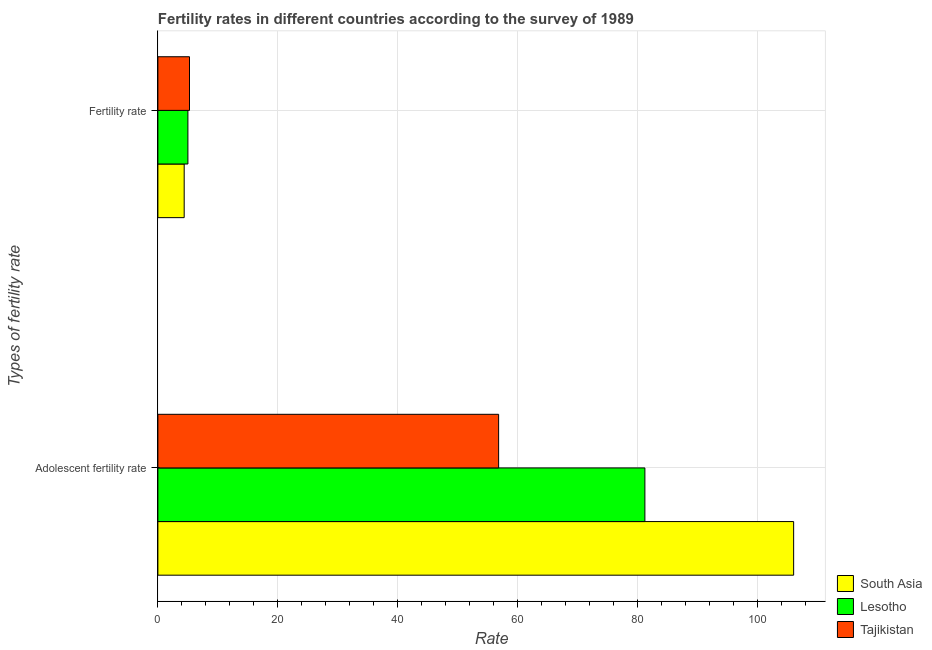How many different coloured bars are there?
Your answer should be very brief. 3. Are the number of bars per tick equal to the number of legend labels?
Ensure brevity in your answer.  Yes. Are the number of bars on each tick of the Y-axis equal?
Ensure brevity in your answer.  Yes. How many bars are there on the 2nd tick from the top?
Ensure brevity in your answer.  3. How many bars are there on the 1st tick from the bottom?
Offer a very short reply. 3. What is the label of the 2nd group of bars from the top?
Your response must be concise. Adolescent fertility rate. What is the adolescent fertility rate in Lesotho?
Provide a short and direct response. 81.17. Across all countries, what is the maximum adolescent fertility rate?
Your answer should be very brief. 105.96. Across all countries, what is the minimum fertility rate?
Make the answer very short. 4.38. In which country was the adolescent fertility rate maximum?
Your response must be concise. South Asia. In which country was the adolescent fertility rate minimum?
Offer a very short reply. Tajikistan. What is the total fertility rate in the graph?
Your answer should be compact. 14.66. What is the difference between the fertility rate in Tajikistan and that in Lesotho?
Offer a very short reply. 0.27. What is the difference between the adolescent fertility rate in Tajikistan and the fertility rate in Lesotho?
Your response must be concise. 51.79. What is the average fertility rate per country?
Make the answer very short. 4.89. What is the difference between the fertility rate and adolescent fertility rate in Tajikistan?
Your answer should be very brief. -51.52. What is the ratio of the adolescent fertility rate in South Asia to that in Tajikistan?
Make the answer very short. 1.87. Is the adolescent fertility rate in South Asia less than that in Tajikistan?
Provide a short and direct response. No. In how many countries, is the fertility rate greater than the average fertility rate taken over all countries?
Give a very brief answer. 2. What does the 2nd bar from the top in Adolescent fertility rate represents?
Your answer should be very brief. Lesotho. What does the 2nd bar from the bottom in Adolescent fertility rate represents?
Make the answer very short. Lesotho. How many bars are there?
Offer a terse response. 6. How many countries are there in the graph?
Provide a short and direct response. 3. What is the difference between two consecutive major ticks on the X-axis?
Ensure brevity in your answer.  20. Are the values on the major ticks of X-axis written in scientific E-notation?
Offer a very short reply. No. Does the graph contain any zero values?
Provide a succinct answer. No. Where does the legend appear in the graph?
Ensure brevity in your answer.  Bottom right. How are the legend labels stacked?
Offer a very short reply. Vertical. What is the title of the graph?
Give a very brief answer. Fertility rates in different countries according to the survey of 1989. Does "Pacific island small states" appear as one of the legend labels in the graph?
Provide a short and direct response. No. What is the label or title of the X-axis?
Keep it short and to the point. Rate. What is the label or title of the Y-axis?
Offer a very short reply. Types of fertility rate. What is the Rate in South Asia in Adolescent fertility rate?
Provide a succinct answer. 105.96. What is the Rate in Lesotho in Adolescent fertility rate?
Keep it short and to the point. 81.17. What is the Rate in Tajikistan in Adolescent fertility rate?
Ensure brevity in your answer.  56.79. What is the Rate in South Asia in Fertility rate?
Offer a terse response. 4.38. What is the Rate of Lesotho in Fertility rate?
Offer a very short reply. 5. What is the Rate of Tajikistan in Fertility rate?
Keep it short and to the point. 5.27. Across all Types of fertility rate, what is the maximum Rate in South Asia?
Provide a short and direct response. 105.96. Across all Types of fertility rate, what is the maximum Rate of Lesotho?
Keep it short and to the point. 81.17. Across all Types of fertility rate, what is the maximum Rate in Tajikistan?
Keep it short and to the point. 56.79. Across all Types of fertility rate, what is the minimum Rate in South Asia?
Your answer should be compact. 4.38. Across all Types of fertility rate, what is the minimum Rate of Lesotho?
Provide a succinct answer. 5. Across all Types of fertility rate, what is the minimum Rate in Tajikistan?
Make the answer very short. 5.27. What is the total Rate in South Asia in the graph?
Offer a very short reply. 110.35. What is the total Rate of Lesotho in the graph?
Offer a terse response. 86.17. What is the total Rate in Tajikistan in the graph?
Offer a terse response. 62.06. What is the difference between the Rate of South Asia in Adolescent fertility rate and that in Fertility rate?
Offer a terse response. 101.58. What is the difference between the Rate in Lesotho in Adolescent fertility rate and that in Fertility rate?
Keep it short and to the point. 76.17. What is the difference between the Rate in Tajikistan in Adolescent fertility rate and that in Fertility rate?
Provide a short and direct response. 51.52. What is the difference between the Rate in South Asia in Adolescent fertility rate and the Rate in Lesotho in Fertility rate?
Keep it short and to the point. 100.96. What is the difference between the Rate in South Asia in Adolescent fertility rate and the Rate in Tajikistan in Fertility rate?
Provide a succinct answer. 100.69. What is the difference between the Rate in Lesotho in Adolescent fertility rate and the Rate in Tajikistan in Fertility rate?
Provide a short and direct response. 75.9. What is the average Rate in South Asia per Types of fertility rate?
Make the answer very short. 55.17. What is the average Rate of Lesotho per Types of fertility rate?
Keep it short and to the point. 43.09. What is the average Rate in Tajikistan per Types of fertility rate?
Your answer should be very brief. 31.03. What is the difference between the Rate in South Asia and Rate in Lesotho in Adolescent fertility rate?
Give a very brief answer. 24.79. What is the difference between the Rate of South Asia and Rate of Tajikistan in Adolescent fertility rate?
Your answer should be very brief. 49.17. What is the difference between the Rate of Lesotho and Rate of Tajikistan in Adolescent fertility rate?
Provide a succinct answer. 24.38. What is the difference between the Rate of South Asia and Rate of Lesotho in Fertility rate?
Offer a very short reply. -0.62. What is the difference between the Rate in South Asia and Rate in Tajikistan in Fertility rate?
Provide a succinct answer. -0.89. What is the difference between the Rate in Lesotho and Rate in Tajikistan in Fertility rate?
Make the answer very short. -0.27. What is the ratio of the Rate in South Asia in Adolescent fertility rate to that in Fertility rate?
Provide a short and direct response. 24.17. What is the ratio of the Rate in Lesotho in Adolescent fertility rate to that in Fertility rate?
Provide a short and direct response. 16.22. What is the ratio of the Rate in Tajikistan in Adolescent fertility rate to that in Fertility rate?
Provide a short and direct response. 10.78. What is the difference between the highest and the second highest Rate of South Asia?
Keep it short and to the point. 101.58. What is the difference between the highest and the second highest Rate of Lesotho?
Keep it short and to the point. 76.17. What is the difference between the highest and the second highest Rate of Tajikistan?
Make the answer very short. 51.52. What is the difference between the highest and the lowest Rate in South Asia?
Give a very brief answer. 101.58. What is the difference between the highest and the lowest Rate in Lesotho?
Offer a terse response. 76.17. What is the difference between the highest and the lowest Rate in Tajikistan?
Provide a succinct answer. 51.52. 